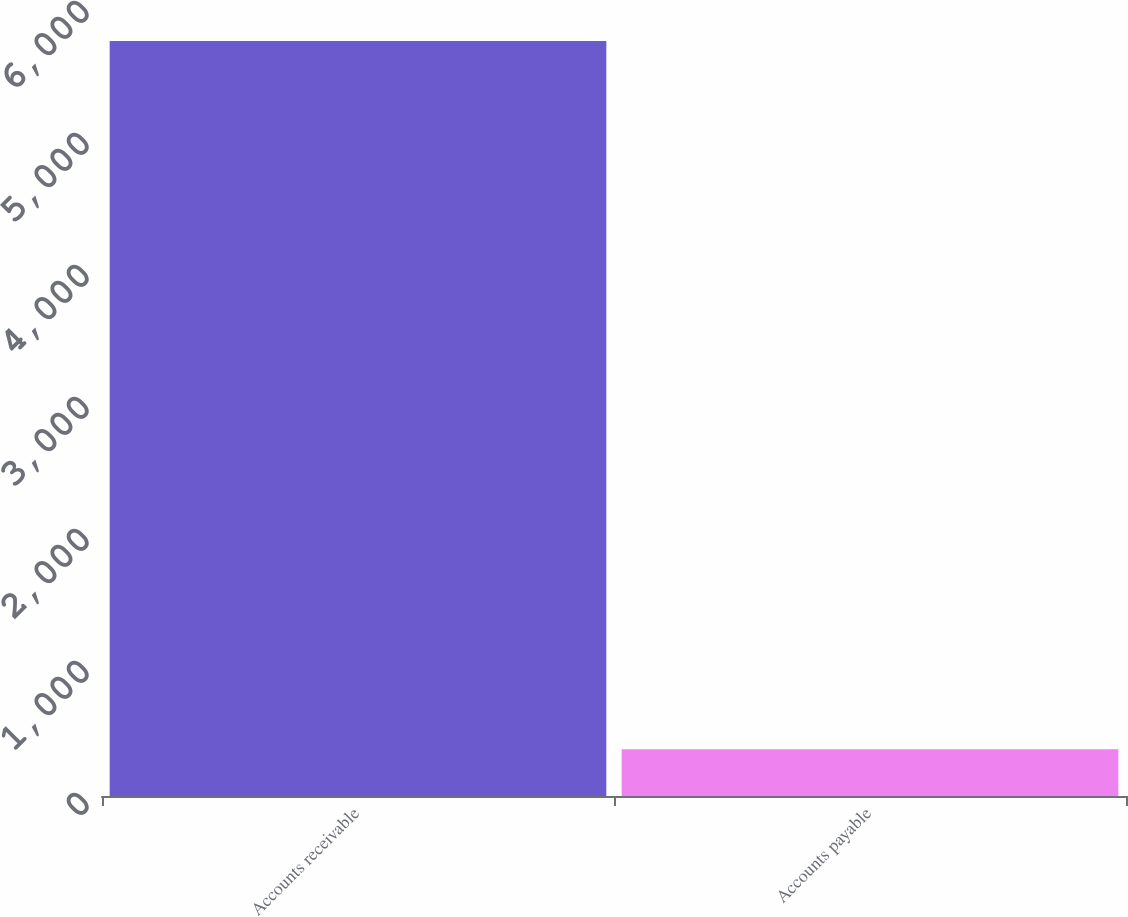Convert chart to OTSL. <chart><loc_0><loc_0><loc_500><loc_500><bar_chart><fcel>Accounts receivable<fcel>Accounts payable<nl><fcel>5719<fcel>354<nl></chart> 